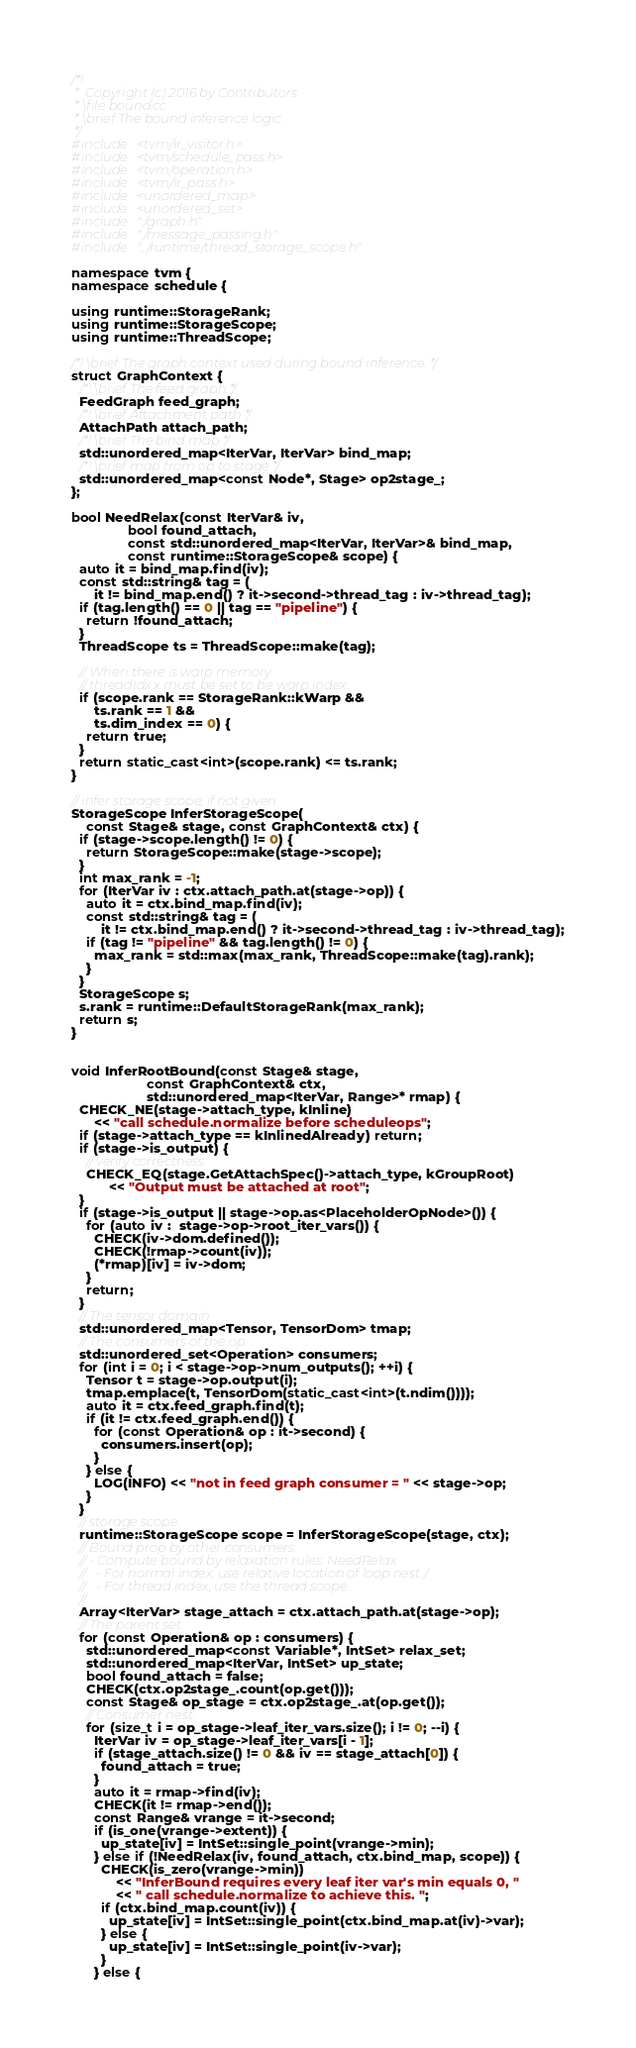Convert code to text. <code><loc_0><loc_0><loc_500><loc_500><_C++_>/*!
 *  Copyright (c) 2016 by Contributors
 * \file bound.cc
 * \brief The bound inference logic.
 */
#include <tvm/ir_visitor.h>
#include <tvm/schedule_pass.h>
#include <tvm/operation.h>
#include <tvm/ir_pass.h>
#include <unordered_map>
#include <unordered_set>
#include "./graph.h"
#include "./message_passing.h"
#include "../runtime/thread_storage_scope.h"

namespace tvm {
namespace schedule {

using runtime::StorageRank;
using runtime::StorageScope;
using runtime::ThreadScope;

/*! \brief The graph context used during bound inference. */
struct GraphContext {
  /*! \brief The feed graph */
  FeedGraph feed_graph;
  /*! \brief Attachment path */
  AttachPath attach_path;
  /*! \brief The bind map */
  std::unordered_map<IterVar, IterVar> bind_map;
  /*! \brief map from op to stage */
  std::unordered_map<const Node*, Stage> op2stage_;
};

bool NeedRelax(const IterVar& iv,
               bool found_attach,
               const std::unordered_map<IterVar, IterVar>& bind_map,
               const runtime::StorageScope& scope) {
  auto it = bind_map.find(iv);
  const std::string& tag = (
      it != bind_map.end() ? it->second->thread_tag : iv->thread_tag);
  if (tag.length() == 0 || tag == "pipeline") {
    return !found_attach;
  }
  ThreadScope ts = ThreadScope::make(tag);

  // When there is warp memory
  // threadIdx.x must be set to be warp index.
  if (scope.rank == StorageRank::kWarp &&
      ts.rank == 1 &&
      ts.dim_index == 0) {
    return true;
  }
  return static_cast<int>(scope.rank) <= ts.rank;
}

// infer storage scope, if not given
StorageScope InferStorageScope(
    const Stage& stage, const GraphContext& ctx) {
  if (stage->scope.length() != 0) {
    return StorageScope::make(stage->scope);
  }
  int max_rank = -1;
  for (IterVar iv : ctx.attach_path.at(stage->op)) {
    auto it = ctx.bind_map.find(iv);
    const std::string& tag = (
        it != ctx.bind_map.end() ? it->second->thread_tag : iv->thread_tag);
    if (tag != "pipeline" && tag.length() != 0) {
      max_rank = std::max(max_rank, ThreadScope::make(tag).rank);
    }
  }
  StorageScope s;
  s.rank = runtime::DefaultStorageRank(max_rank);
  return s;
}


void InferRootBound(const Stage& stage,
                    const GraphContext& ctx,
                    std::unordered_map<IterVar, Range>* rmap) {
  CHECK_NE(stage->attach_type, kInline)
      << "call schedule.normalize before scheduleops";
  if (stage->attach_type == kInlinedAlready) return;
  if (stage->is_output) {
    // verify correctness.
    CHECK_EQ(stage.GetAttachSpec()->attach_type, kGroupRoot)
          << "Output must be attached at root";
  }
  if (stage->is_output || stage->op.as<PlaceholderOpNode>()) {
    for (auto iv :  stage->op->root_iter_vars()) {
      CHECK(iv->dom.defined());
      CHECK(!rmap->count(iv));
      (*rmap)[iv] = iv->dom;
    }
    return;
  }
  // The tensor domain.
  std::unordered_map<Tensor, TensorDom> tmap;
  // The consumers of the op.
  std::unordered_set<Operation> consumers;
  for (int i = 0; i < stage->op->num_outputs(); ++i) {
    Tensor t = stage->op.output(i);
    tmap.emplace(t, TensorDom(static_cast<int>(t.ndim())));
    auto it = ctx.feed_graph.find(t);
    if (it != ctx.feed_graph.end()) {
      for (const Operation& op : it->second) {
        consumers.insert(op);
      }
    } else {
      LOG(INFO) << "not in feed graph consumer = " << stage->op;
    }
  }
  // storage scope.
  runtime::StorageScope scope = InferStorageScope(stage, ctx);
  // Bound prop by other consumers.
  // - Compute bound by relaxation rules: NeedRelax
  //   - For normal index, use relative location of loop nest./
  //   - For thread index, use the thread scope.
  //
  Array<IterVar> stage_attach = ctx.attach_path.at(stage->op);
  // The parent set.
  for (const Operation& op : consumers) {
    std::unordered_map<const Variable*, IntSet> relax_set;
    std::unordered_map<IterVar, IntSet> up_state;
    bool found_attach = false;
    CHECK(ctx.op2stage_.count(op.get()));
    const Stage& op_stage = ctx.op2stage_.at(op.get());
    // Consumer nest
    for (size_t i = op_stage->leaf_iter_vars.size(); i != 0; --i) {
      IterVar iv = op_stage->leaf_iter_vars[i - 1];
      if (stage_attach.size() != 0 && iv == stage_attach[0]) {
        found_attach = true;
      }
      auto it = rmap->find(iv);
      CHECK(it != rmap->end());
      const Range& vrange = it->second;
      if (is_one(vrange->extent)) {
        up_state[iv] = IntSet::single_point(vrange->min);
      } else if (!NeedRelax(iv, found_attach, ctx.bind_map, scope)) {
        CHECK(is_zero(vrange->min))
            << "InferBound requires every leaf iter var's min equals 0, "
            << " call schedule.normalize to achieve this. ";
        if (ctx.bind_map.count(iv)) {
          up_state[iv] = IntSet::single_point(ctx.bind_map.at(iv)->var);
        } else {
          up_state[iv] = IntSet::single_point(iv->var);
        }
      } else {</code> 